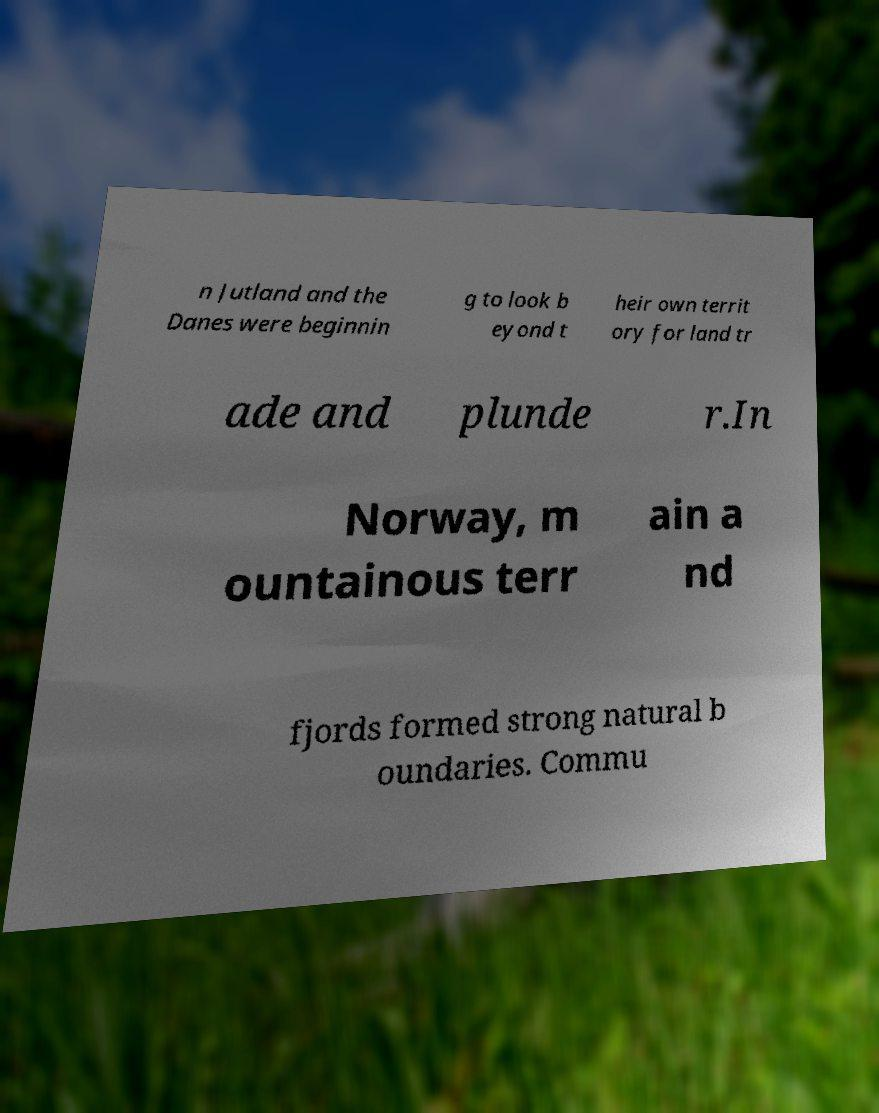I need the written content from this picture converted into text. Can you do that? n Jutland and the Danes were beginnin g to look b eyond t heir own territ ory for land tr ade and plunde r.In Norway, m ountainous terr ain a nd fjords formed strong natural b oundaries. Commu 